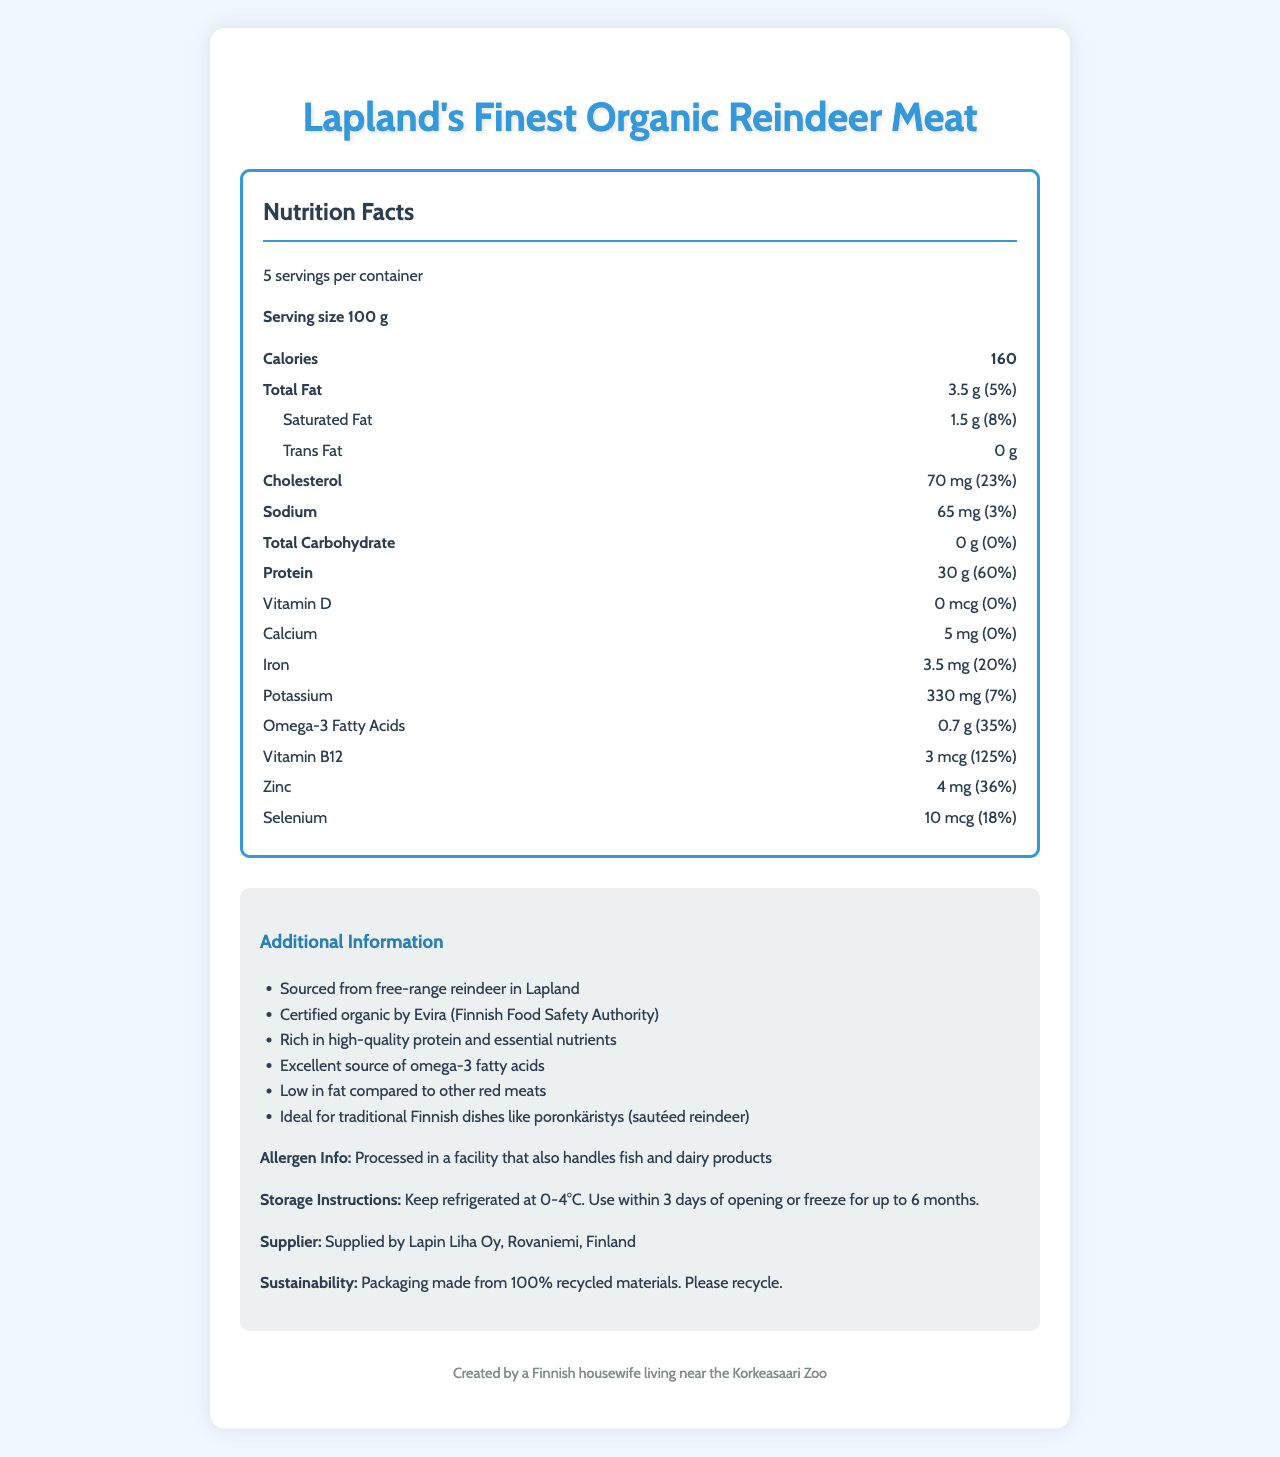what is the serving size? The serving size is directly mentioned as "Serving size 100 g" in the document.
Answer: 100 g how many servings are in the container? The document mentions "5 servings per container".
Answer: 5 what is the amount of protein per serving? The document lists "Protein 30 g" under the Nutrition Facts section.
Answer: 30 g what percentage of the daily value of omega-3 fatty acids does one serving provide? The percentage daily value for omega-3 fatty acids is listed as "35%" next to "Omega-3 Fatty Acids".
Answer: 35% what is the calorie count per serving? The document lists "Calories 160" in the Nutrition Facts section.
Answer: 160 which nutrient has the highest daily value percentage per serving? A. Protein B. Cholesterol C. Vitamin B12 D. Iron The highest daily value percentage is for Vitamin B12 at "125%".
Answer: C which of the following is not found in significant amounts in organic reindeer meat? A. Trans Fat B. Dietary Fiber C. Total Sugars D. All of the above The document lists "Trans Fat 0 g", "Dietary Fiber 0 g", and "Total Sugars 0 g", meaning all of these nutrients are not found in significant amounts.
Answer: D is the product low in fat compared to other red meats? The additional information states, "Low in fat compared to other red meats".
Answer: Yes summarize the document. The document provides detailed nutrition facts, additional product information, allergen info, storage instructions, supplier details, and sustainability notes regarding the organic reindeer meat product.
Answer: Lapland's Finest Organic Reindeer Meat is a nutrient-rich product with high protein content and a good source of omega-3 fatty acids. Each 100 g serving contains 160 calories, 3.5 g of total fat, 70 mg cholesterol, 65 mg sodium, and no carbohydrates. It is free from trans fats, sugars, and dietary fiber. The product provides significant amounts of protein (60% DV), omega-3 fatty acids (35% DV), vitamin B12 (125% DV), zinc (36% DV), and other essential nutrients. Certified organic and sourced from free-range reindeer, it is additionally noted to be low in fat compared to other red meats. what is the amount of added sugars per serving? The document clearly lists "Added Sugars 0 g" under the Nutrition Facts section.
Answer: 0 g who certifies that the reindeer meat is organic? The additional information mentions "Certified organic by Evira (Finnish Food Safety Authority)".
Answer: Evira (Finnish Food Safety Authority) which company supplies the reindeer meat? The document specifies that the supplier is "Lapin Liha Oy, Rovaniemi, Finland".
Answer: Lapin Liha Oy, Rovaniemi, Finland is the product processed in a facility that handles dairy products? The allergen information states, "Processed in a facility that also handles fish and dairy products".
Answer: Yes what is the storage temperature range for this product? The storage instructions mention, "Keep refrigerated at 0-4°C".
Answer: 0-4°C how long can you freeze the reindeer meat? The storage instructions state the product can be frozen "for up to 6 months".
Answer: Up to 6 months what is the main ingredient of Lapland's Finest Organic Reindeer Meat? The document does not provide information about the specific ingredients, only nutrition facts and other product details.
Answer: Cannot be determined 